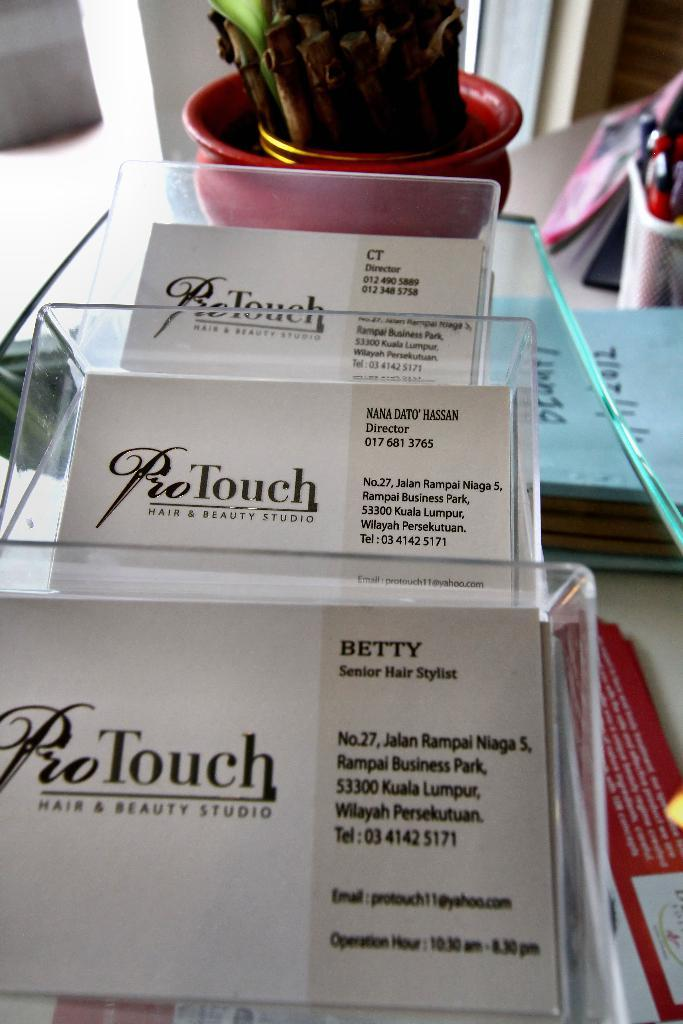What type of business cards are on the table in the image? There are visiting cards of a salon on the table. What can be seen behind the visiting cards? There is a bamboo plant behind the visiting cards. What is located on the right side of the table? There are books and stationary items on the right side of the table. What type of creature is interacting with the stationary items on the table? There is no creature present in the image; it only shows visiting cards, a bamboo plant, books, and stationary items on a table. 